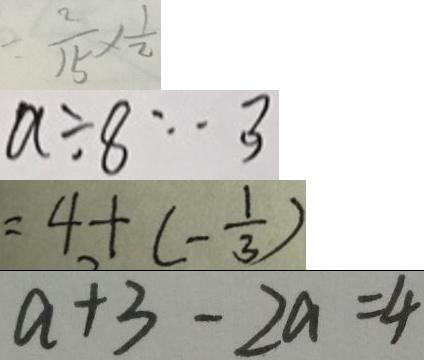Convert formula to latex. <formula><loc_0><loc_0><loc_500><loc_500>= \frac { 2 } { 1 5 } \times \frac { 1 } { 2 } 
 a \div 8 \cdots 3 
 = 4 + ( - \frac { 1 } { 3 } ) 
 a + 3 - 2 a = 4</formula> 